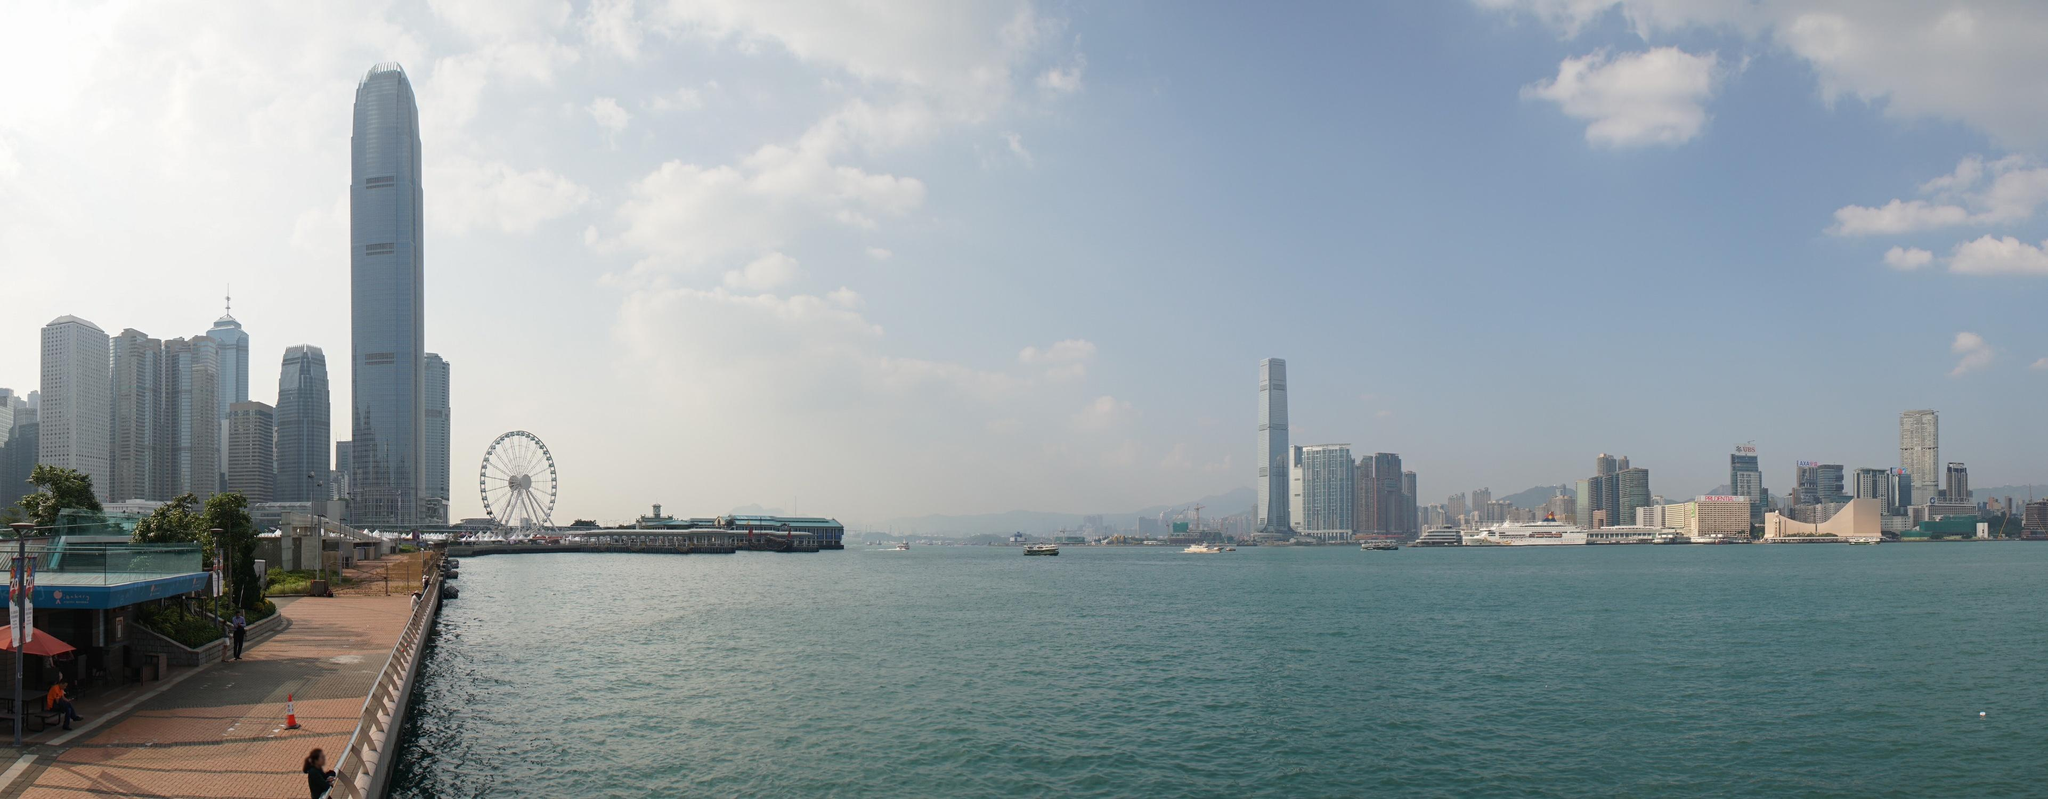If you could add any fantastical element to this scene, what would it be and why? What if the ferris wheel in this image were enchanted, with each of its cabins transforming into a different mythical creature's nest when it reaches the top? Imagine fairies, dragons, and phoenixes taking flight from their nests as the wheel turns, adding a magical aura to the already stunning skyline of Hong Kong. This fantastical element would capture the hearts and imaginations of both locals and visitors, adding an element of fantasy and wonder to the urban landscape. 